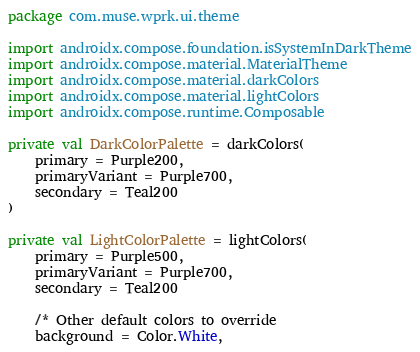Convert code to text. <code><loc_0><loc_0><loc_500><loc_500><_Kotlin_>package com.muse.wprk.ui.theme

import androidx.compose.foundation.isSystemInDarkTheme
import androidx.compose.material.MaterialTheme
import androidx.compose.material.darkColors
import androidx.compose.material.lightColors
import androidx.compose.runtime.Composable

private val DarkColorPalette = darkColors(
    primary = Purple200,
    primaryVariant = Purple700,
    secondary = Teal200
)

private val LightColorPalette = lightColors(
    primary = Purple500,
    primaryVariant = Purple700,
    secondary = Teal200

    /* Other default colors to override
    background = Color.White,</code> 